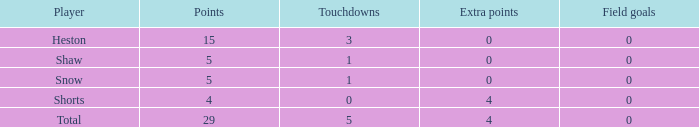What is the sum of all the touchdowns when the player had more than 0 extra points and less than 0 field goals? None. 